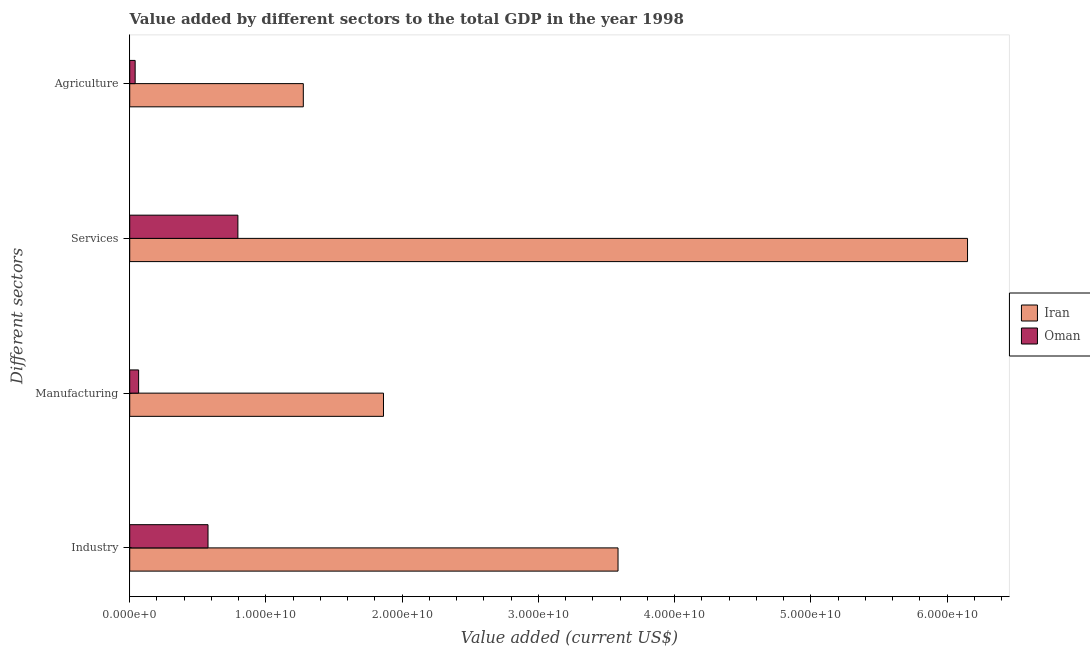Are the number of bars per tick equal to the number of legend labels?
Keep it short and to the point. Yes. How many bars are there on the 4th tick from the top?
Keep it short and to the point. 2. What is the label of the 4th group of bars from the top?
Offer a very short reply. Industry. What is the value added by services sector in Oman?
Offer a very short reply. 7.94e+09. Across all countries, what is the maximum value added by services sector?
Ensure brevity in your answer.  6.15e+1. Across all countries, what is the minimum value added by industrial sector?
Offer a terse response. 5.75e+09. In which country was the value added by manufacturing sector maximum?
Make the answer very short. Iran. In which country was the value added by agricultural sector minimum?
Offer a very short reply. Oman. What is the total value added by agricultural sector in the graph?
Your response must be concise. 1.31e+1. What is the difference between the value added by manufacturing sector in Iran and that in Oman?
Your response must be concise. 1.80e+1. What is the difference between the value added by industrial sector in Oman and the value added by agricultural sector in Iran?
Provide a succinct answer. -7.00e+09. What is the average value added by industrial sector per country?
Make the answer very short. 2.08e+1. What is the difference between the value added by agricultural sector and value added by manufacturing sector in Oman?
Provide a succinct answer. -2.55e+08. In how many countries, is the value added by industrial sector greater than 50000000000 US$?
Make the answer very short. 0. What is the ratio of the value added by agricultural sector in Iran to that in Oman?
Your answer should be compact. 31.98. Is the difference between the value added by agricultural sector in Oman and Iran greater than the difference between the value added by services sector in Oman and Iran?
Give a very brief answer. Yes. What is the difference between the highest and the second highest value added by manufacturing sector?
Offer a very short reply. 1.80e+1. What is the difference between the highest and the lowest value added by services sector?
Give a very brief answer. 5.36e+1. Is the sum of the value added by industrial sector in Iran and Oman greater than the maximum value added by agricultural sector across all countries?
Provide a succinct answer. Yes. Is it the case that in every country, the sum of the value added by services sector and value added by agricultural sector is greater than the sum of value added by industrial sector and value added by manufacturing sector?
Ensure brevity in your answer.  No. What does the 2nd bar from the top in Manufacturing represents?
Keep it short and to the point. Iran. What does the 1st bar from the bottom in Agriculture represents?
Your answer should be very brief. Iran. How many bars are there?
Offer a terse response. 8. Are all the bars in the graph horizontal?
Your answer should be very brief. Yes. How many countries are there in the graph?
Your response must be concise. 2. What is the difference between two consecutive major ticks on the X-axis?
Your response must be concise. 1.00e+1. Are the values on the major ticks of X-axis written in scientific E-notation?
Make the answer very short. Yes. Does the graph contain grids?
Give a very brief answer. No. Where does the legend appear in the graph?
Your response must be concise. Center right. How many legend labels are there?
Ensure brevity in your answer.  2. What is the title of the graph?
Give a very brief answer. Value added by different sectors to the total GDP in the year 1998. Does "Brazil" appear as one of the legend labels in the graph?
Give a very brief answer. No. What is the label or title of the X-axis?
Provide a succinct answer. Value added (current US$). What is the label or title of the Y-axis?
Offer a very short reply. Different sectors. What is the Value added (current US$) in Iran in Industry?
Offer a very short reply. 3.58e+1. What is the Value added (current US$) in Oman in Industry?
Keep it short and to the point. 5.75e+09. What is the Value added (current US$) of Iran in Manufacturing?
Ensure brevity in your answer.  1.86e+1. What is the Value added (current US$) of Oman in Manufacturing?
Make the answer very short. 6.54e+08. What is the Value added (current US$) of Iran in Services?
Offer a very short reply. 6.15e+1. What is the Value added (current US$) in Oman in Services?
Offer a terse response. 7.94e+09. What is the Value added (current US$) in Iran in Agriculture?
Provide a succinct answer. 1.27e+1. What is the Value added (current US$) in Oman in Agriculture?
Your answer should be very brief. 3.98e+08. Across all Different sectors, what is the maximum Value added (current US$) of Iran?
Make the answer very short. 6.15e+1. Across all Different sectors, what is the maximum Value added (current US$) of Oman?
Make the answer very short. 7.94e+09. Across all Different sectors, what is the minimum Value added (current US$) of Iran?
Offer a very short reply. 1.27e+1. Across all Different sectors, what is the minimum Value added (current US$) in Oman?
Your answer should be very brief. 3.98e+08. What is the total Value added (current US$) in Iran in the graph?
Give a very brief answer. 1.29e+11. What is the total Value added (current US$) of Oman in the graph?
Offer a very short reply. 1.47e+1. What is the difference between the Value added (current US$) of Iran in Industry and that in Manufacturing?
Keep it short and to the point. 1.72e+1. What is the difference between the Value added (current US$) of Oman in Industry and that in Manufacturing?
Your answer should be very brief. 5.09e+09. What is the difference between the Value added (current US$) of Iran in Industry and that in Services?
Ensure brevity in your answer.  -2.57e+1. What is the difference between the Value added (current US$) of Oman in Industry and that in Services?
Keep it short and to the point. -2.19e+09. What is the difference between the Value added (current US$) in Iran in Industry and that in Agriculture?
Provide a succinct answer. 2.31e+1. What is the difference between the Value added (current US$) in Oman in Industry and that in Agriculture?
Keep it short and to the point. 5.35e+09. What is the difference between the Value added (current US$) in Iran in Manufacturing and that in Services?
Provide a short and direct response. -4.29e+1. What is the difference between the Value added (current US$) in Oman in Manufacturing and that in Services?
Offer a terse response. -7.29e+09. What is the difference between the Value added (current US$) in Iran in Manufacturing and that in Agriculture?
Give a very brief answer. 5.88e+09. What is the difference between the Value added (current US$) in Oman in Manufacturing and that in Agriculture?
Ensure brevity in your answer.  2.55e+08. What is the difference between the Value added (current US$) of Iran in Services and that in Agriculture?
Ensure brevity in your answer.  4.88e+1. What is the difference between the Value added (current US$) of Oman in Services and that in Agriculture?
Provide a succinct answer. 7.54e+09. What is the difference between the Value added (current US$) in Iran in Industry and the Value added (current US$) in Oman in Manufacturing?
Offer a very short reply. 3.52e+1. What is the difference between the Value added (current US$) of Iran in Industry and the Value added (current US$) of Oman in Services?
Offer a very short reply. 2.79e+1. What is the difference between the Value added (current US$) of Iran in Industry and the Value added (current US$) of Oman in Agriculture?
Keep it short and to the point. 3.54e+1. What is the difference between the Value added (current US$) in Iran in Manufacturing and the Value added (current US$) in Oman in Services?
Keep it short and to the point. 1.07e+1. What is the difference between the Value added (current US$) of Iran in Manufacturing and the Value added (current US$) of Oman in Agriculture?
Your response must be concise. 1.82e+1. What is the difference between the Value added (current US$) in Iran in Services and the Value added (current US$) in Oman in Agriculture?
Offer a very short reply. 6.11e+1. What is the average Value added (current US$) of Iran per Different sectors?
Offer a very short reply. 3.22e+1. What is the average Value added (current US$) in Oman per Different sectors?
Your answer should be compact. 3.68e+09. What is the difference between the Value added (current US$) of Iran and Value added (current US$) of Oman in Industry?
Your response must be concise. 3.01e+1. What is the difference between the Value added (current US$) of Iran and Value added (current US$) of Oman in Manufacturing?
Give a very brief answer. 1.80e+1. What is the difference between the Value added (current US$) of Iran and Value added (current US$) of Oman in Services?
Your answer should be very brief. 5.36e+1. What is the difference between the Value added (current US$) of Iran and Value added (current US$) of Oman in Agriculture?
Give a very brief answer. 1.23e+1. What is the ratio of the Value added (current US$) in Iran in Industry to that in Manufacturing?
Your response must be concise. 1.92. What is the ratio of the Value added (current US$) in Oman in Industry to that in Manufacturing?
Make the answer very short. 8.79. What is the ratio of the Value added (current US$) of Iran in Industry to that in Services?
Offer a very short reply. 0.58. What is the ratio of the Value added (current US$) in Oman in Industry to that in Services?
Keep it short and to the point. 0.72. What is the ratio of the Value added (current US$) of Iran in Industry to that in Agriculture?
Provide a succinct answer. 2.81. What is the ratio of the Value added (current US$) in Oman in Industry to that in Agriculture?
Give a very brief answer. 14.42. What is the ratio of the Value added (current US$) in Iran in Manufacturing to that in Services?
Your answer should be compact. 0.3. What is the ratio of the Value added (current US$) of Oman in Manufacturing to that in Services?
Offer a very short reply. 0.08. What is the ratio of the Value added (current US$) of Iran in Manufacturing to that in Agriculture?
Your response must be concise. 1.46. What is the ratio of the Value added (current US$) of Oman in Manufacturing to that in Agriculture?
Keep it short and to the point. 1.64. What is the ratio of the Value added (current US$) of Iran in Services to that in Agriculture?
Keep it short and to the point. 4.83. What is the ratio of the Value added (current US$) of Oman in Services to that in Agriculture?
Ensure brevity in your answer.  19.93. What is the difference between the highest and the second highest Value added (current US$) in Iran?
Keep it short and to the point. 2.57e+1. What is the difference between the highest and the second highest Value added (current US$) of Oman?
Your answer should be compact. 2.19e+09. What is the difference between the highest and the lowest Value added (current US$) of Iran?
Offer a very short reply. 4.88e+1. What is the difference between the highest and the lowest Value added (current US$) in Oman?
Your answer should be very brief. 7.54e+09. 